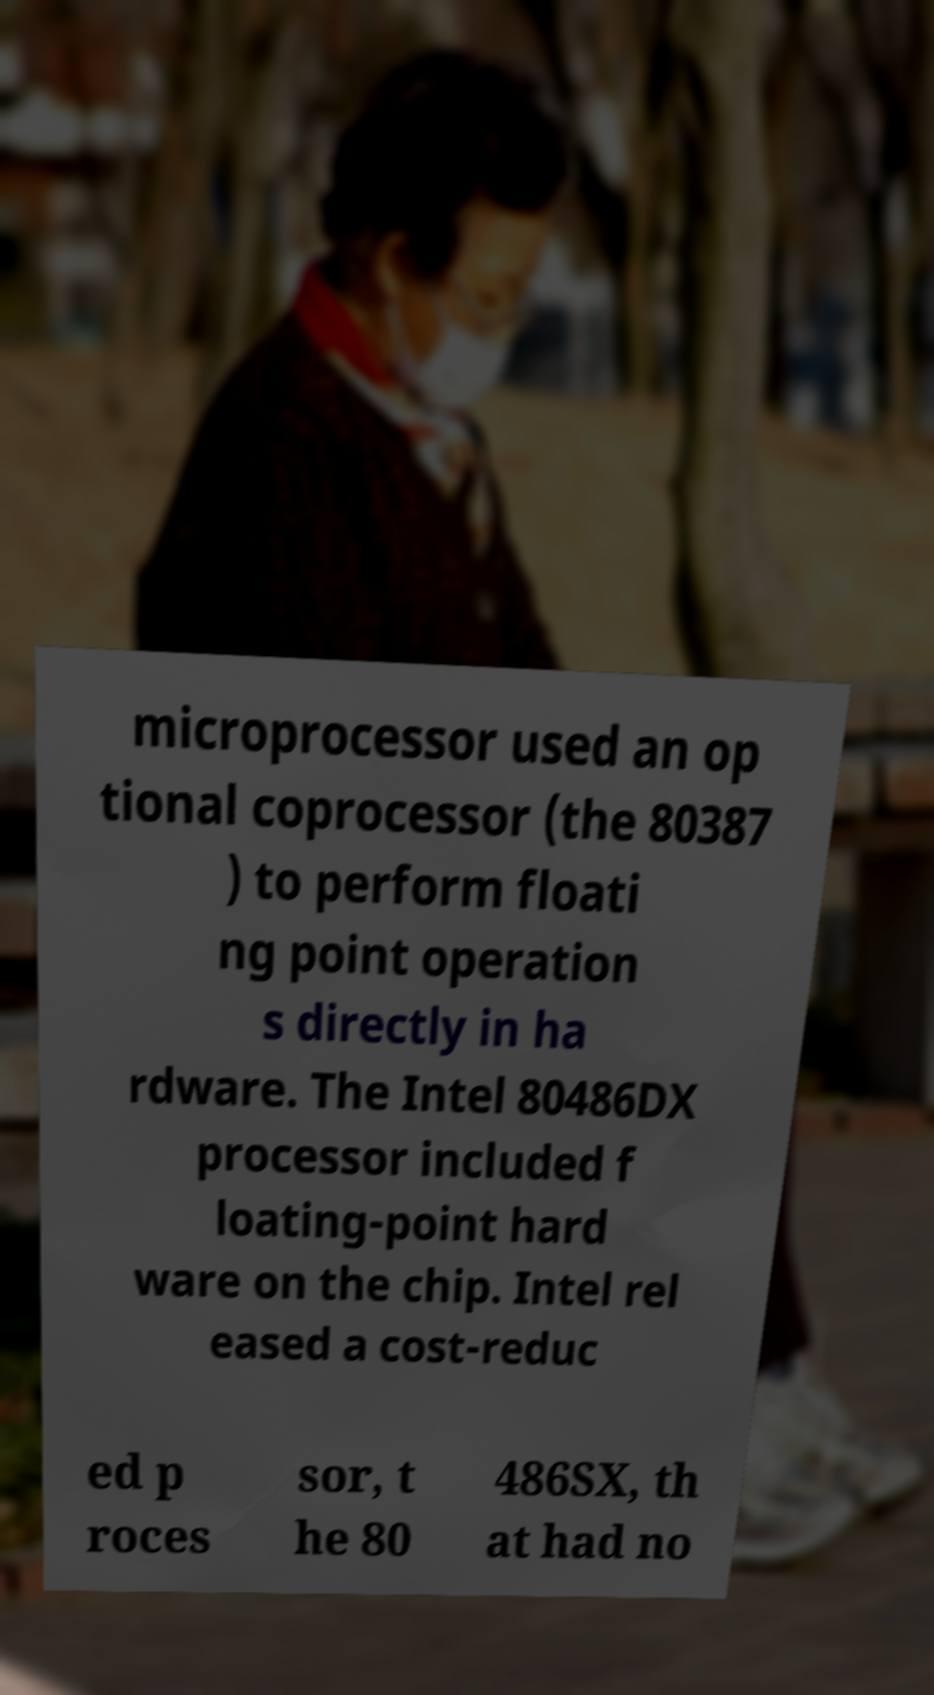Could you extract and type out the text from this image? microprocessor used an op tional coprocessor (the 80387 ) to perform floati ng point operation s directly in ha rdware. The Intel 80486DX processor included f loating-point hard ware on the chip. Intel rel eased a cost-reduc ed p roces sor, t he 80 486SX, th at had no 